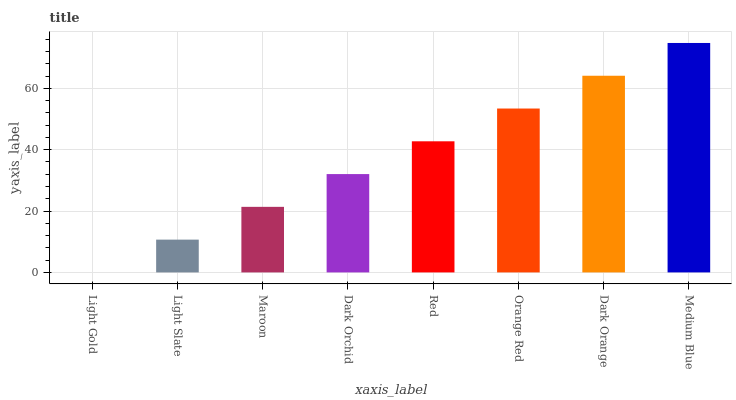Is Light Gold the minimum?
Answer yes or no. Yes. Is Medium Blue the maximum?
Answer yes or no. Yes. Is Light Slate the minimum?
Answer yes or no. No. Is Light Slate the maximum?
Answer yes or no. No. Is Light Slate greater than Light Gold?
Answer yes or no. Yes. Is Light Gold less than Light Slate?
Answer yes or no. Yes. Is Light Gold greater than Light Slate?
Answer yes or no. No. Is Light Slate less than Light Gold?
Answer yes or no. No. Is Red the high median?
Answer yes or no. Yes. Is Dark Orchid the low median?
Answer yes or no. Yes. Is Light Slate the high median?
Answer yes or no. No. Is Maroon the low median?
Answer yes or no. No. 